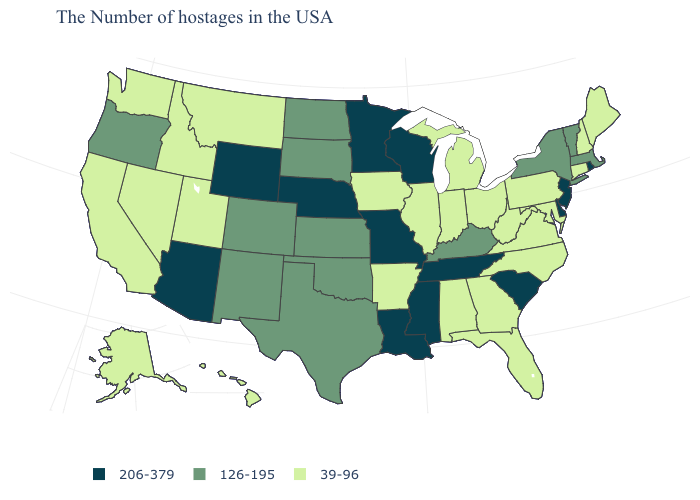Among the states that border Vermont , does New Hampshire have the lowest value?
Short answer required. Yes. Name the states that have a value in the range 206-379?
Be succinct. Rhode Island, New Jersey, Delaware, South Carolina, Tennessee, Wisconsin, Mississippi, Louisiana, Missouri, Minnesota, Nebraska, Wyoming, Arizona. Is the legend a continuous bar?
Give a very brief answer. No. Does Michigan have a lower value than New Jersey?
Answer briefly. Yes. Name the states that have a value in the range 206-379?
Keep it brief. Rhode Island, New Jersey, Delaware, South Carolina, Tennessee, Wisconsin, Mississippi, Louisiana, Missouri, Minnesota, Nebraska, Wyoming, Arizona. Among the states that border New Hampshire , which have the highest value?
Concise answer only. Massachusetts, Vermont. What is the lowest value in the USA?
Short answer required. 39-96. What is the value of Massachusetts?
Be succinct. 126-195. What is the value of Hawaii?
Keep it brief. 39-96. Name the states that have a value in the range 39-96?
Give a very brief answer. Maine, New Hampshire, Connecticut, Maryland, Pennsylvania, Virginia, North Carolina, West Virginia, Ohio, Florida, Georgia, Michigan, Indiana, Alabama, Illinois, Arkansas, Iowa, Utah, Montana, Idaho, Nevada, California, Washington, Alaska, Hawaii. Among the states that border Idaho , which have the highest value?
Quick response, please. Wyoming. What is the value of Washington?
Write a very short answer. 39-96. Name the states that have a value in the range 39-96?
Give a very brief answer. Maine, New Hampshire, Connecticut, Maryland, Pennsylvania, Virginia, North Carolina, West Virginia, Ohio, Florida, Georgia, Michigan, Indiana, Alabama, Illinois, Arkansas, Iowa, Utah, Montana, Idaho, Nevada, California, Washington, Alaska, Hawaii. What is the lowest value in the West?
Concise answer only. 39-96. 